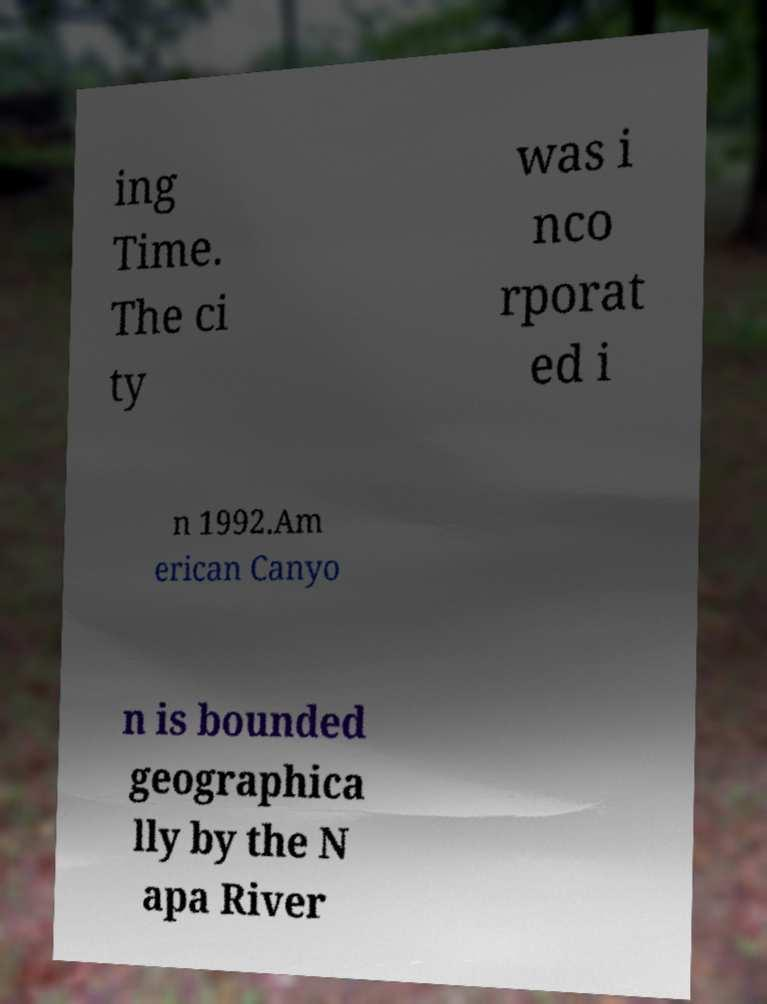What messages or text are displayed in this image? I need them in a readable, typed format. ing Time. The ci ty was i nco rporat ed i n 1992.Am erican Canyo n is bounded geographica lly by the N apa River 